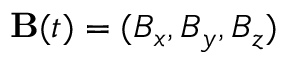<formula> <loc_0><loc_0><loc_500><loc_500>{ B } ( t ) = ( B _ { x } , B _ { y } , B _ { z } )</formula> 